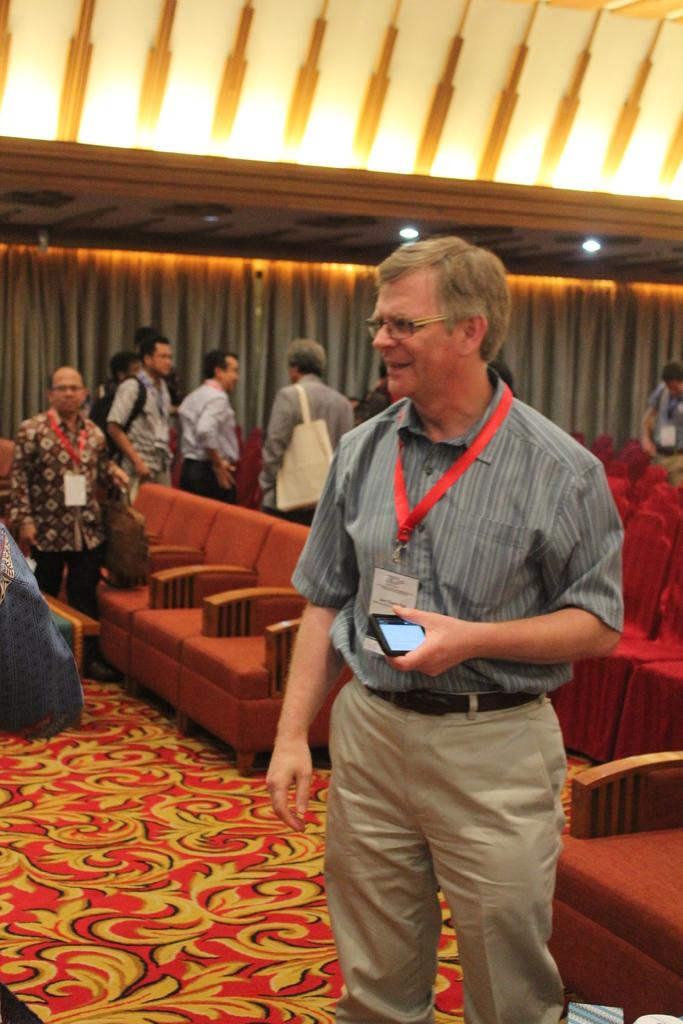What is the man in the image doing? The man is standing on the floor and holding a mobile phone in the image. What else can be seen in the image besides the man? There are chairs, a group of people, curtains, and a roof with ceiling lights in the image. How many people are standing in the image? There is a group of people standing in the image. What might be used to cover or decorate windows in the image? Curtains are present in the image for covering or decorating windows. What type of eggs can be seen on the roof in the image? There are no eggs present on the roof in the image. What kind of bait is being used to attract the cloud in the image? There is no cloud or bait present in the image. 